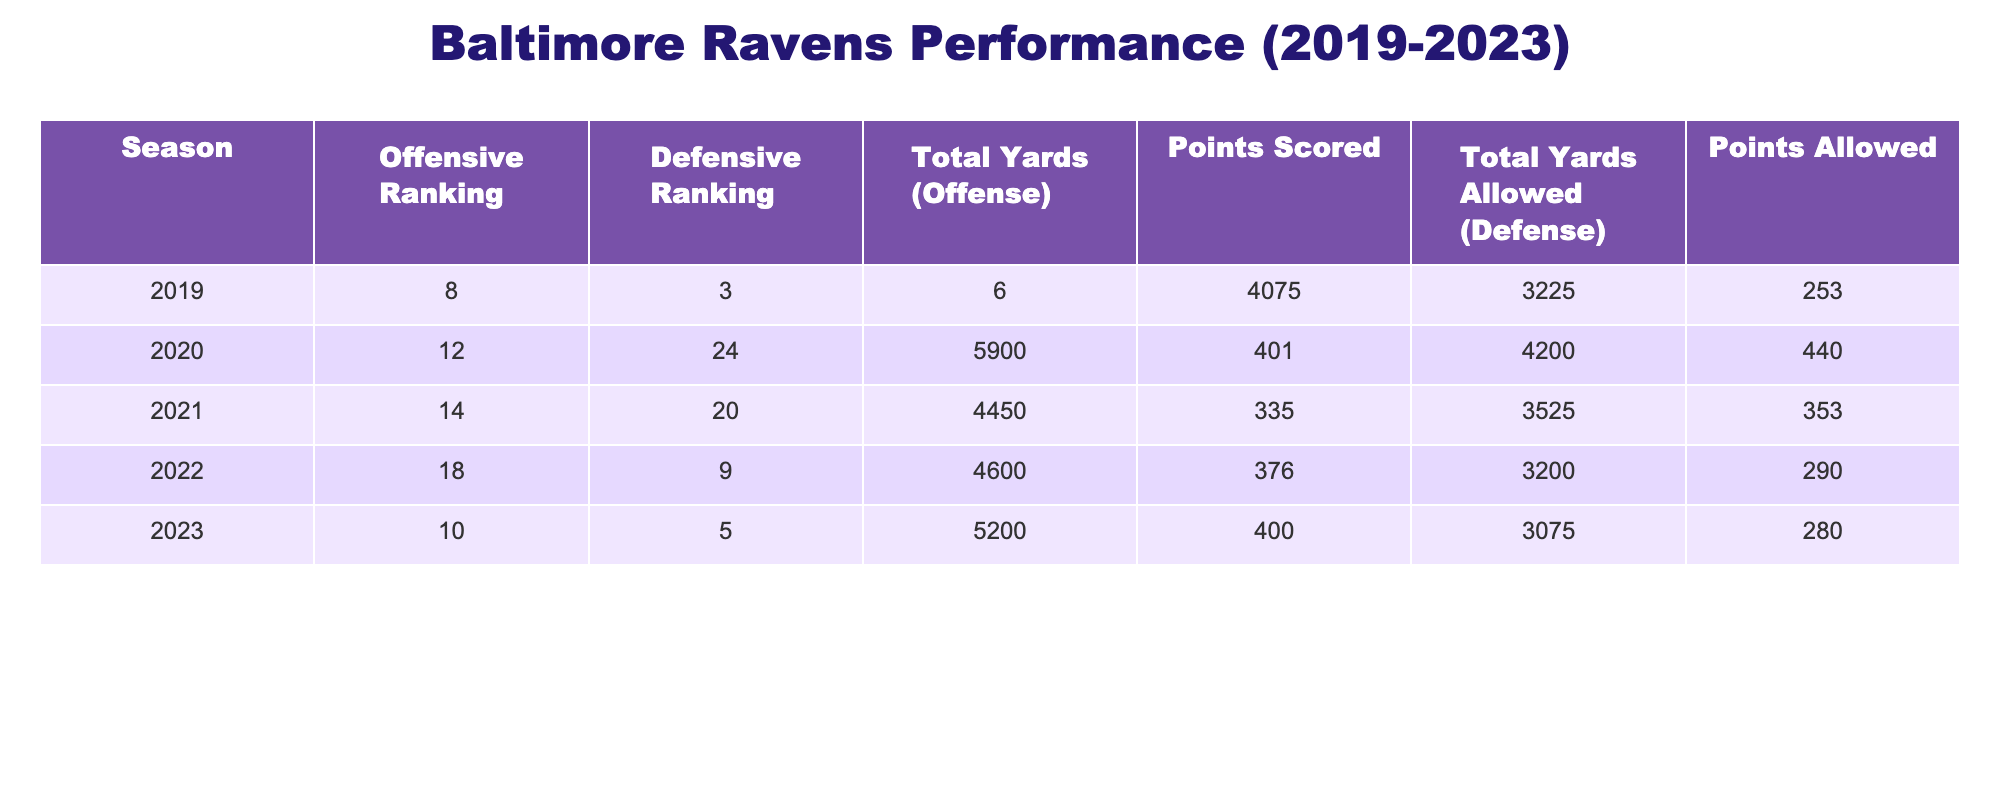What was the Baltimore Ravens' offensive ranking in 2022? The table shows that the offensive ranking for the 2022 season is listed in the corresponding row under the "Offensive Ranking" column. For 2022, the value is 18.
Answer: 18 How many total yards on offense did the Baltimore Ravens accumulate in the 2020 season? Referring to the table, in the row for the 2020 season, the total yards on offense is indicated in the "Total Yards (Offense)" column, which shows 5900.
Answer: 5900 Did the Ravens' defensive ranking improve or decline from 2021 to 2022? By comparing the defensive rankings for the two seasons, we see that in 2021 the ranking was 20 and it improved to 9 in 2022. Therefore, this indicates an improvement.
Answer: Yes What is the difference in points allowed by the Ravens' defense between 2019 and 2023? To find the difference, we subtract the points allowed in 2023 from the points allowed in 2019. This means 253 (2019) - 280 (2023) = -27, indicating that the points allowed increased.
Answer: 27 What is the average offensive ranking of the Baltimore Ravens over the past five seasons? To calculate the average, we sum the offensive rankings from each season: 8 + 12 + 14 + 18 + 10 = 62. Then we divide this sum by the number of seasons (5). So, 62 / 5 = 12.4.
Answer: 12.4 In which season did the Ravens score the most points? Looking at the "Points Scored" column, the highest value is 401 points, which occurs in the 2020 season.
Answer: 2020 Was the Ravens' total yards allowed by defense less in 2022 compared to 2021? In 2021, total yards allowed is 3525, while in 2022, it was lower at 3200. Therefore, they allowed fewer yards in 2022 than in 2021.
Answer: Yes What season had the highest total yards on offense? The table indicates the "Total Yards (Offense)" for each season, and 5900 in 2020 is the highest amount compared to other seasons listed.
Answer: 2020 What is the total sum of points scored by the Ravens from 2019 to 2023? To find the total points scored, add the points from each season: 253 + 401 + 335 + 376 + 400 = 1765.
Answer: 1765 